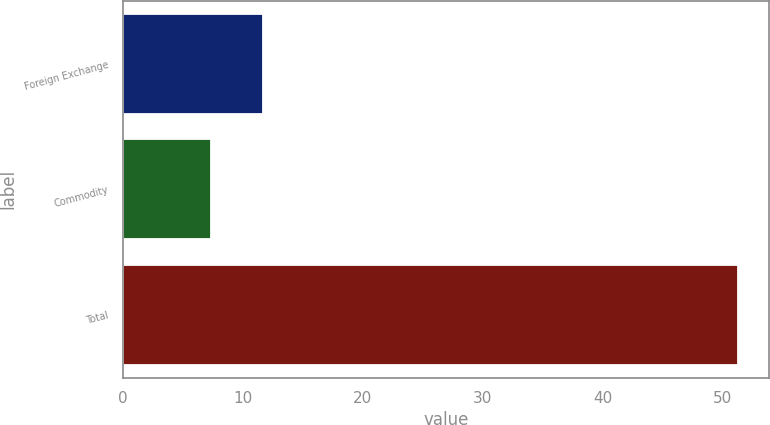Convert chart. <chart><loc_0><loc_0><loc_500><loc_500><bar_chart><fcel>Foreign Exchange<fcel>Commodity<fcel>Total<nl><fcel>11.7<fcel>7.3<fcel>51.3<nl></chart> 